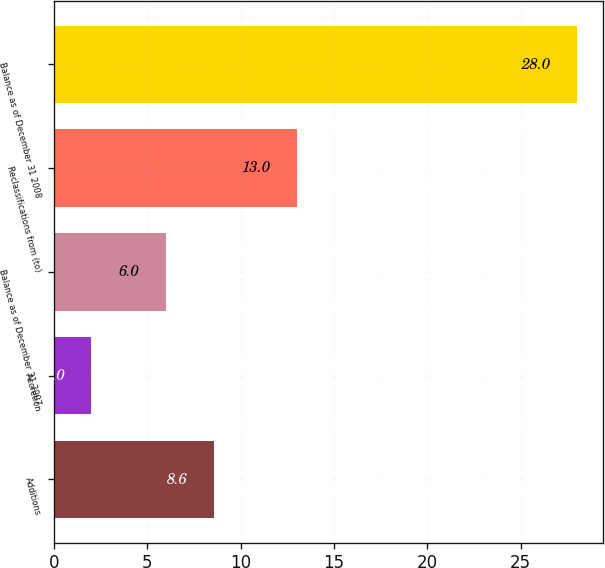Convert chart to OTSL. <chart><loc_0><loc_0><loc_500><loc_500><bar_chart><fcel>Additions<fcel>Accretion<fcel>Balance as of December 31 2007<fcel>Reclassifications from (to)<fcel>Balance as of December 31 2008<nl><fcel>8.6<fcel>2<fcel>6<fcel>13<fcel>28<nl></chart> 